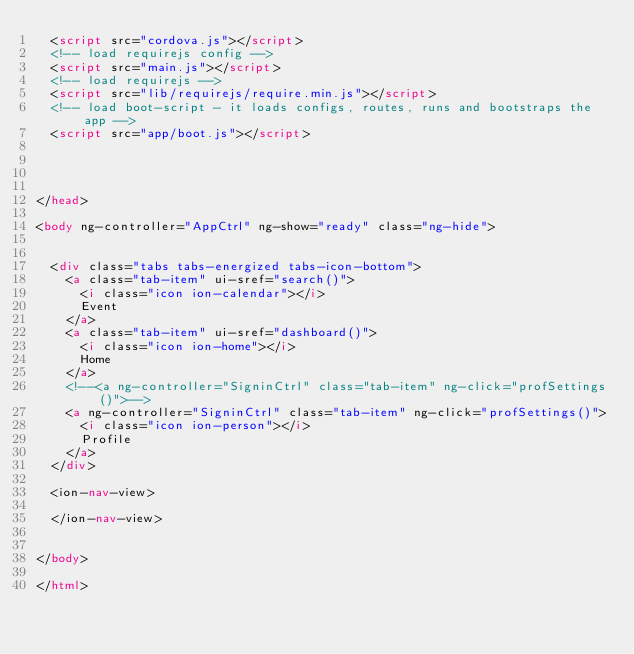<code> <loc_0><loc_0><loc_500><loc_500><_HTML_>  <script src="cordova.js"></script>
  <!-- load requirejs config -->
  <script src="main.js"></script>
  <!-- load requirejs -->
  <script src="lib/requirejs/require.min.js"></script>
  <!-- load boot-script - it loads configs, routes, runs and bootstraps the app -->
  <script src="app/boot.js"></script>




</head>

<body ng-controller="AppCtrl" ng-show="ready" class="ng-hide">


  <div class="tabs tabs-energized tabs-icon-bottom">
    <a class="tab-item" ui-sref="search()">
      <i class="icon ion-calendar"></i>
      Event
    </a>
    <a class="tab-item" ui-sref="dashboard()">
      <i class="icon ion-home"></i>
      Home
    </a>
    <!--<a ng-controller="SigninCtrl" class="tab-item" ng-click="profSettings()">-->
    <a ng-controller="SigninCtrl" class="tab-item" ng-click="profSettings()">
      <i class="icon ion-person"></i>
      Profile
    </a>
  </div>

  <ion-nav-view>

  </ion-nav-view>


</body>

</html>
</code> 